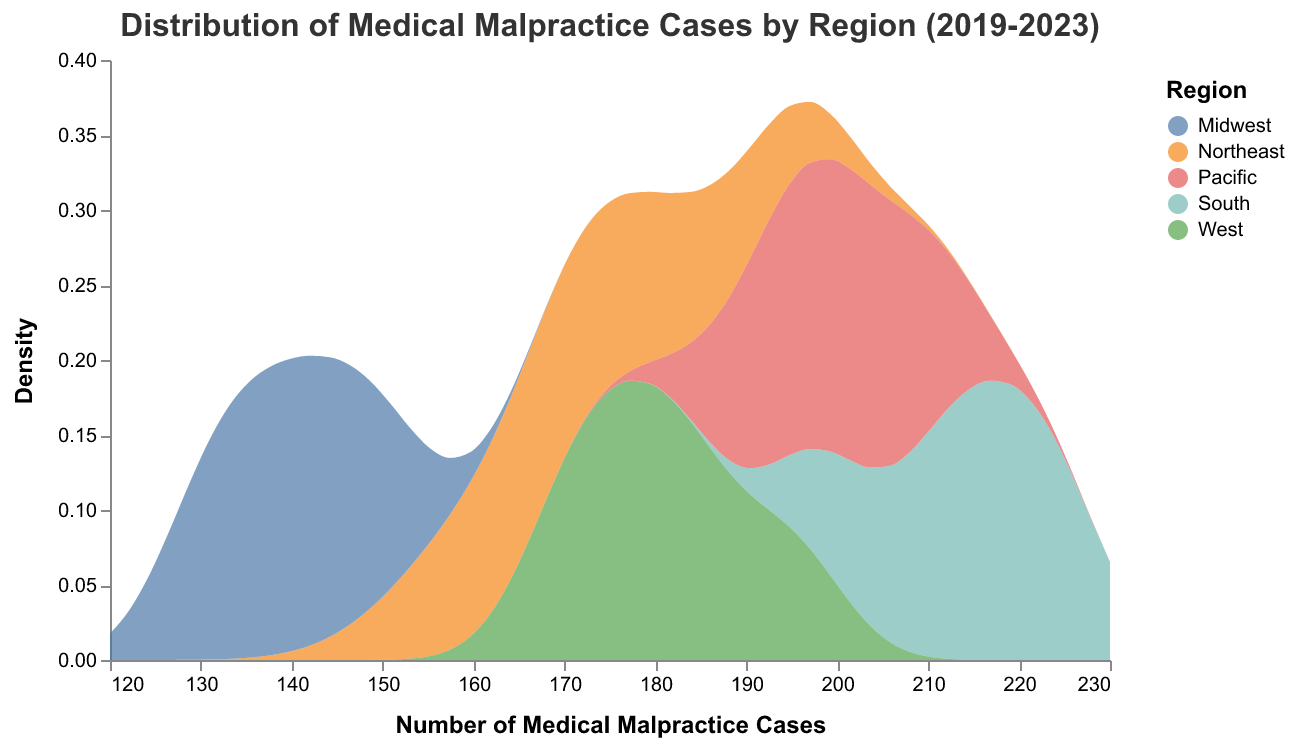What is the title of the plot? The title of the plot is placed at the top and it indicates the subject of the plot. Here, it is "Distribution of Medical Malpractice Cases by Region (2019-2023)".
Answer: Distribution of Medical Malpractice Cases by Region (2019-2023) How many regions are represented in the plot? The legend on the right side of the plot shows different colors corresponding to different regions. Here, five regions are represented: Northeast, Midwest, South, West, and Pacific.
Answer: 5 Which region has the highest density peak for medical malpractice cases? To identify the highest density peak, observe each region's area under the curve. The South region has the highest density peak.
Answer: South What is the range of the number of medical malpractice cases depicted on the x-axis? The x-axis title "Number of Medical Malpractice Cases" shows the range from 120 to 230, as indicated by the extent of data.
Answer: 120 to 230 Which region has the widest spread in the number of medical malpractice cases? The spread is indicated by the width of the density curve along the x-axis. The Northeast region appears to have the widest spread as its curve covers a broader range of cases.
Answer: Northeast What is the approximate median number of medical malpractice cases for the Midwest region? The median can be approximated by finding the midpoint of the density curve of the Midwest region. It lies around 140 cases.
Answer: 140 Which regions have similar density distributions? Similar density distributions can be identified by comparing the shapes and peaks of different regions' curves. The West and Pacific regions have similar density distributions.
Answer: West and Pacific Are there any regions with a clearly increasing trend in medical malpractice cases over the years? By comparing the density peaks over sequential years visually, we can see that the Northeast region shows a trend toward increasing cases over the years.
Answer: Northeast How does the density of medical malpractice cases in the Northeast region compare to other regions? The Northeast region has a moderate density peak and a wide spread compared to other regions. It is neither the highest nor the lowest but has significant variation.
Answer: Moderate density, wide spread 